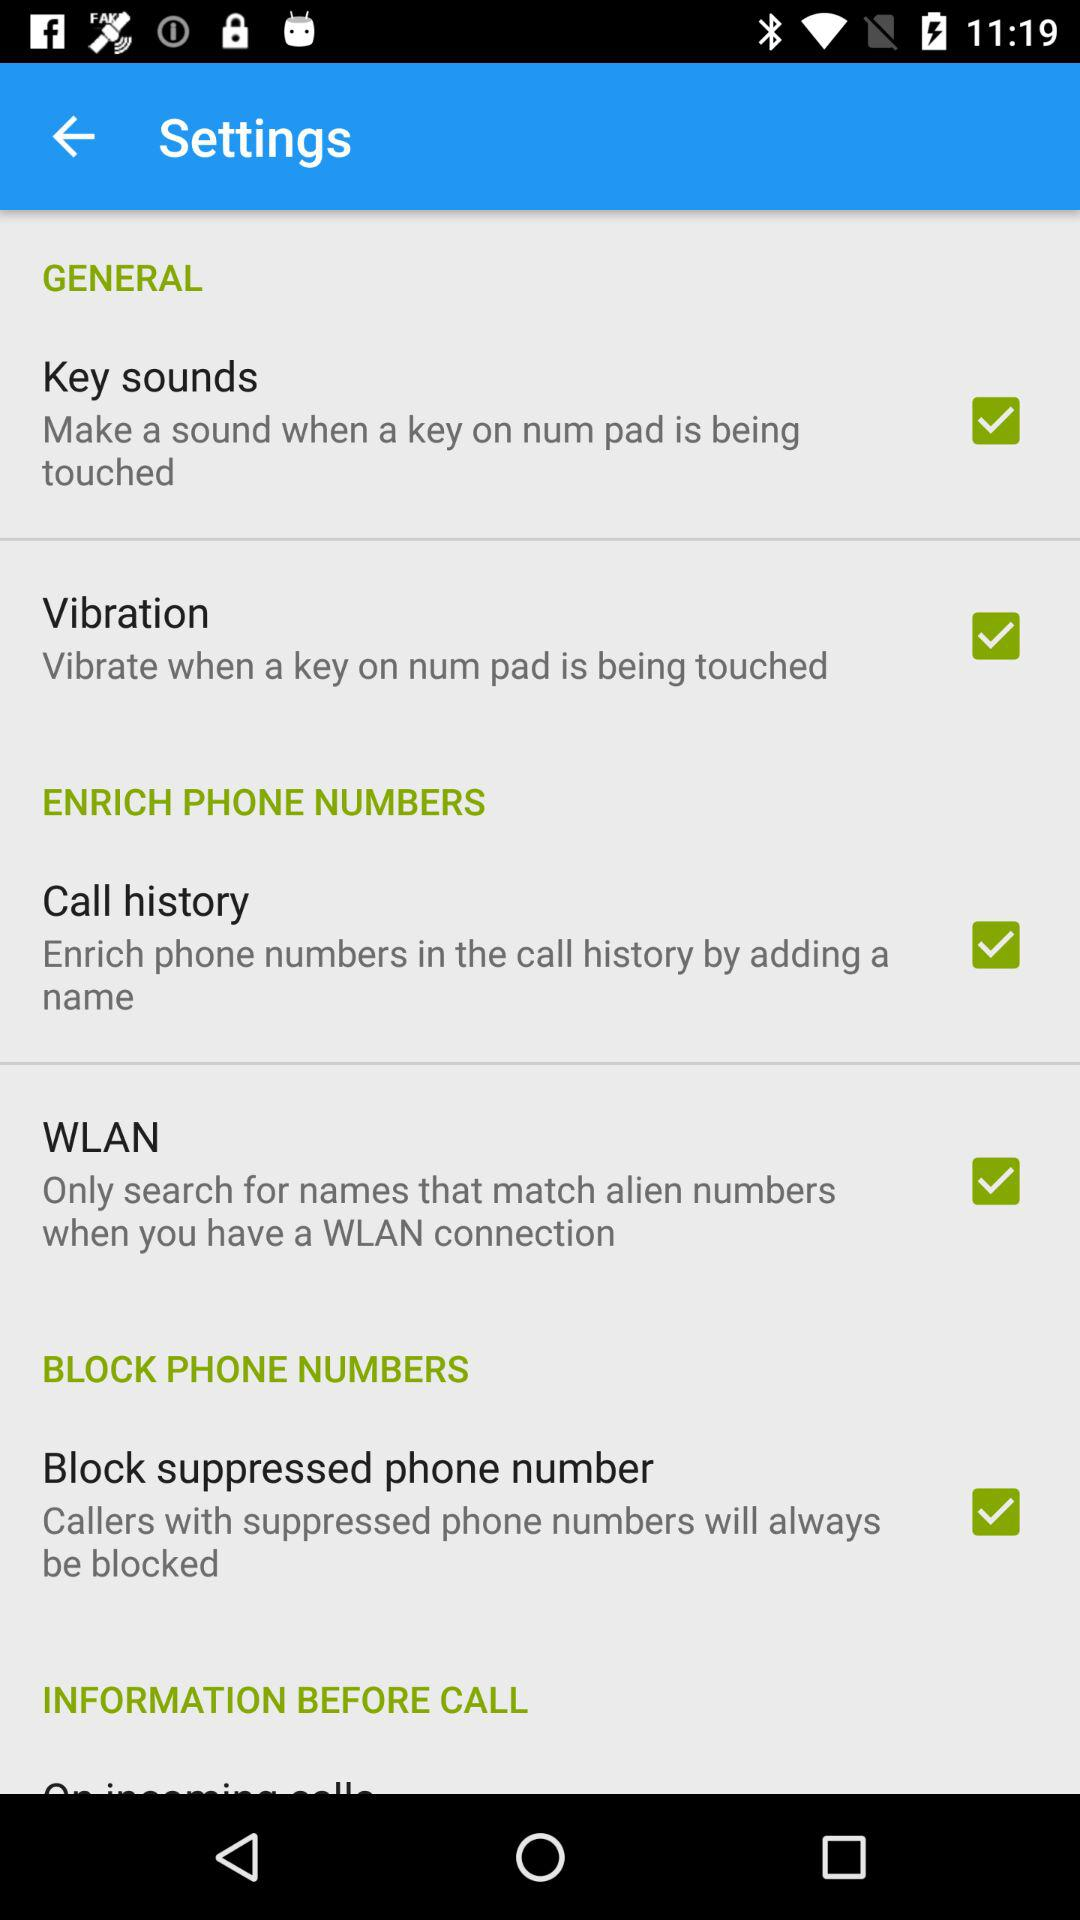What is the status of the option below "INFORMATION BEFORE CALL"?
When the provided information is insufficient, respond with <no answer>. <no answer> 